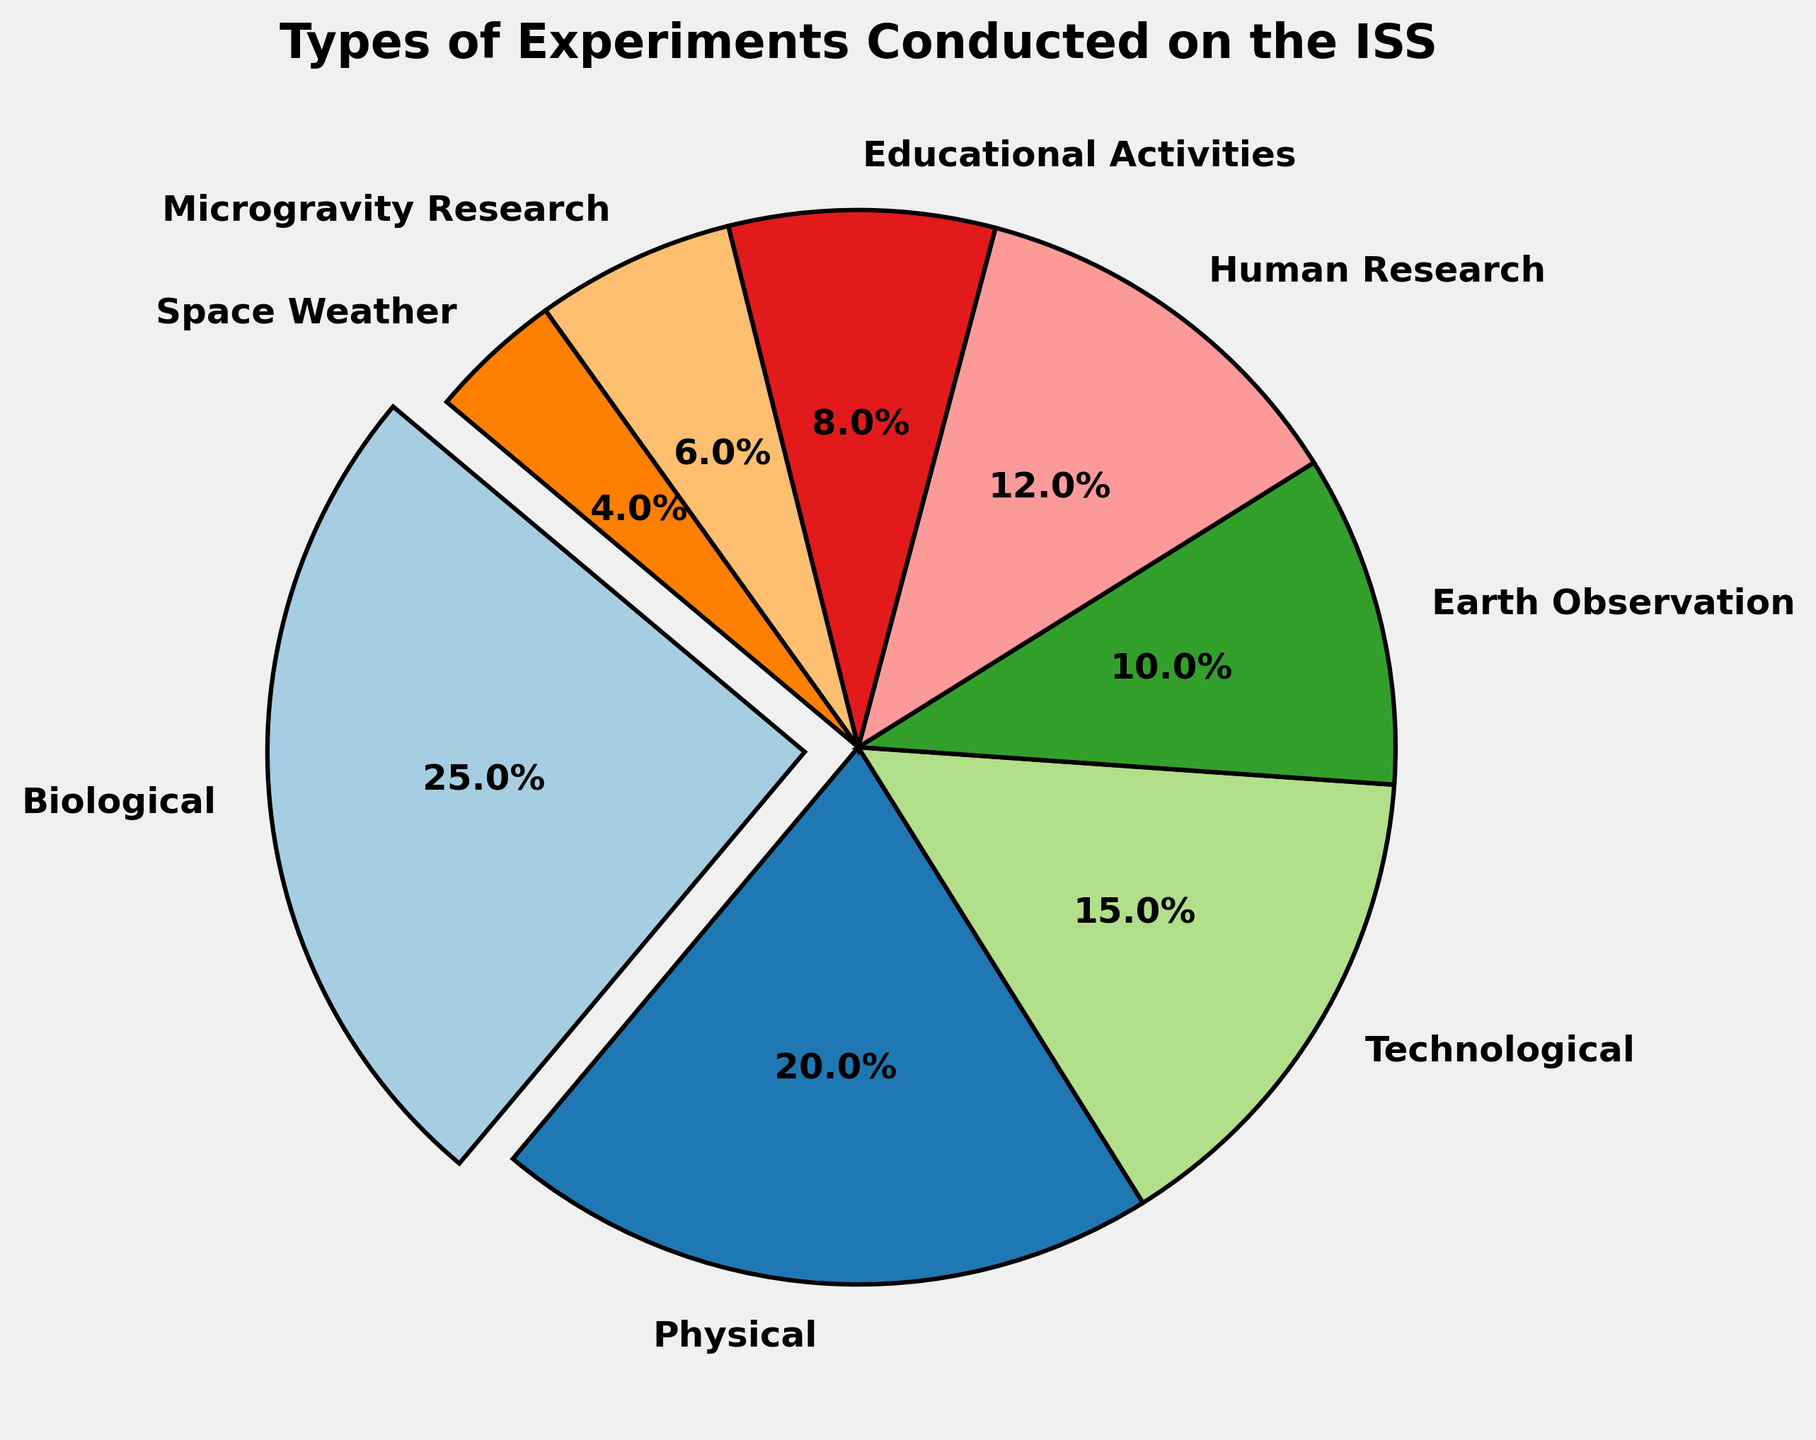Which type of experiment has the highest percentage in the pie chart? The section with the biggest wedge and the percentage label showing the highest value will indicate the highest experiment type. The exploded wedge is Biological at 25%.
Answer: Biological Which types of experiments have a percentage less than 10%? By looking at the size of the wedges and reading the percentage labels, the small slices for Earth Observation, Educational Activities, Microgravity Research, and Space Weather all have percentages below 10%.
Answer: Earth Observation, Educational Activities, Microgravity Research, Space Weather What is the total combined percentage of Biological and Human Research experiments? From the chart, the percentages for Biological and Human Research are 25% and 12%, respectively. Summing them up, 25% + 12% = 37%.
Answer: 37% How do the percentages of Physical and Technological experiments compare? From the chart, the percentage for Physical experiments is 20% and for Technological experiments is 15%. Comparing these two values, Physical experiments have a higher percentage.
Answer: Physical has a higher percentage Which experiment type has the smallest percentage, and what is its percentage? The smallest wedge on the chart shows Space Weather with a percentage of 4%.
Answer: Space Weather, 4% What is the combined percentage of all experiments other than Biological? By subtracting the percentage of Biological experiments from 100%, the other experiments account for 100% - 25% = 75%.
Answer: 75% Are Educational Activities experiments less common than Physical experiments? Checking the percentages, Educational Activities have 8% and Physical experiments have 20%. Yes, Educational Activities are less common.
Answer: Yes Which color wedge corresponds to Educational Activities on the pie chart? The wedge corresponding to Educational Activities is observed to have a specific color, which should be checked visually on the chart. (Color identification will vary by the viewer's interpretation based on the provided palette).
Answer: (Color varies) If you sum the percentages for Technological, Microgravity Research, and Space Weather, what do you get? Adding the percentages for Technological (15%), Microgravity Research (6%), and Space Weather (4%), we get 15% + 6% + 4% = 25%.
Answer: 25% Is the percentage of Earth Observation experiments greater than the percentage of Human Research experiments? Comparing the percentages from the chart, Earth Observation is at 10% and Human Research is at 12%. Earth Observation is not greater.
Answer: No 